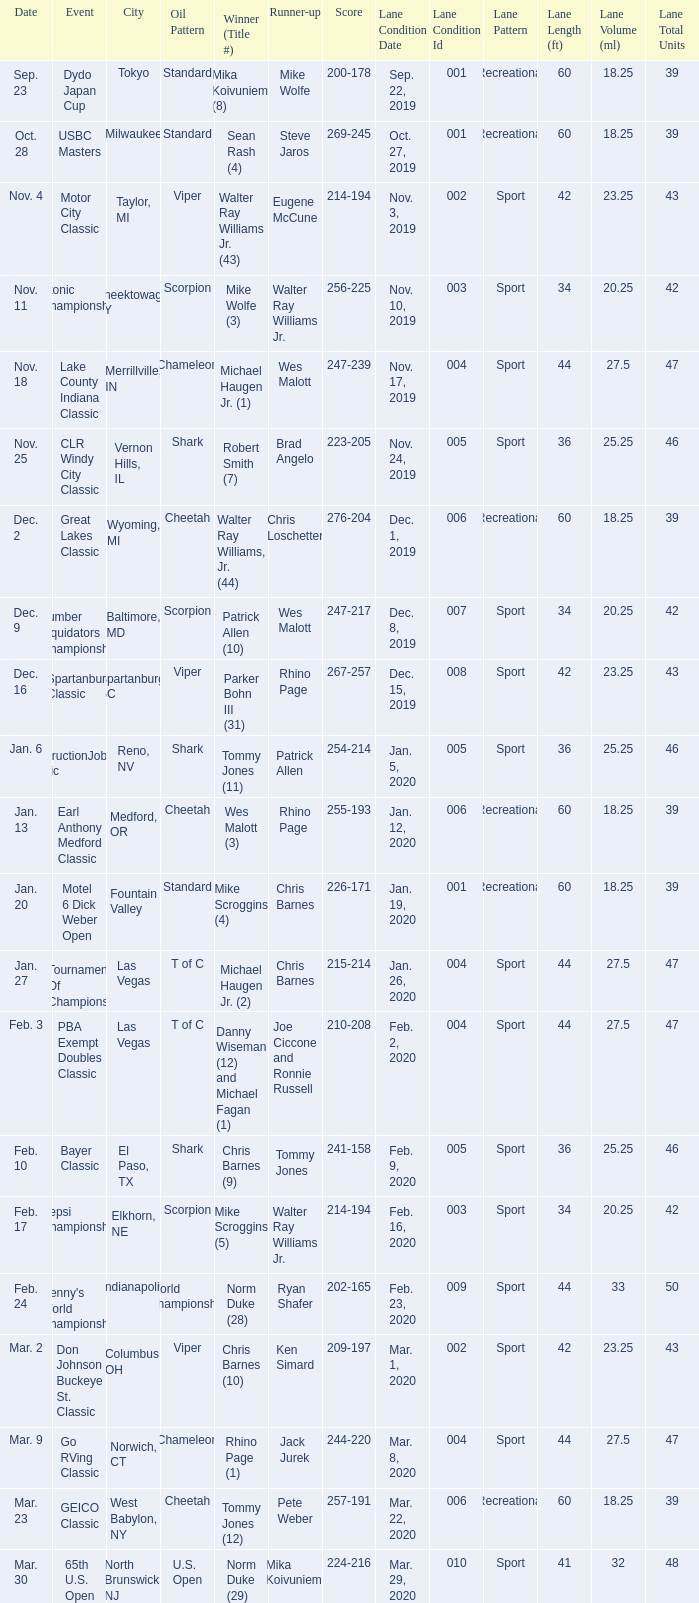Which Oil Pattern has a Winner (Title #) of mike wolfe (3)? Scorpion. 